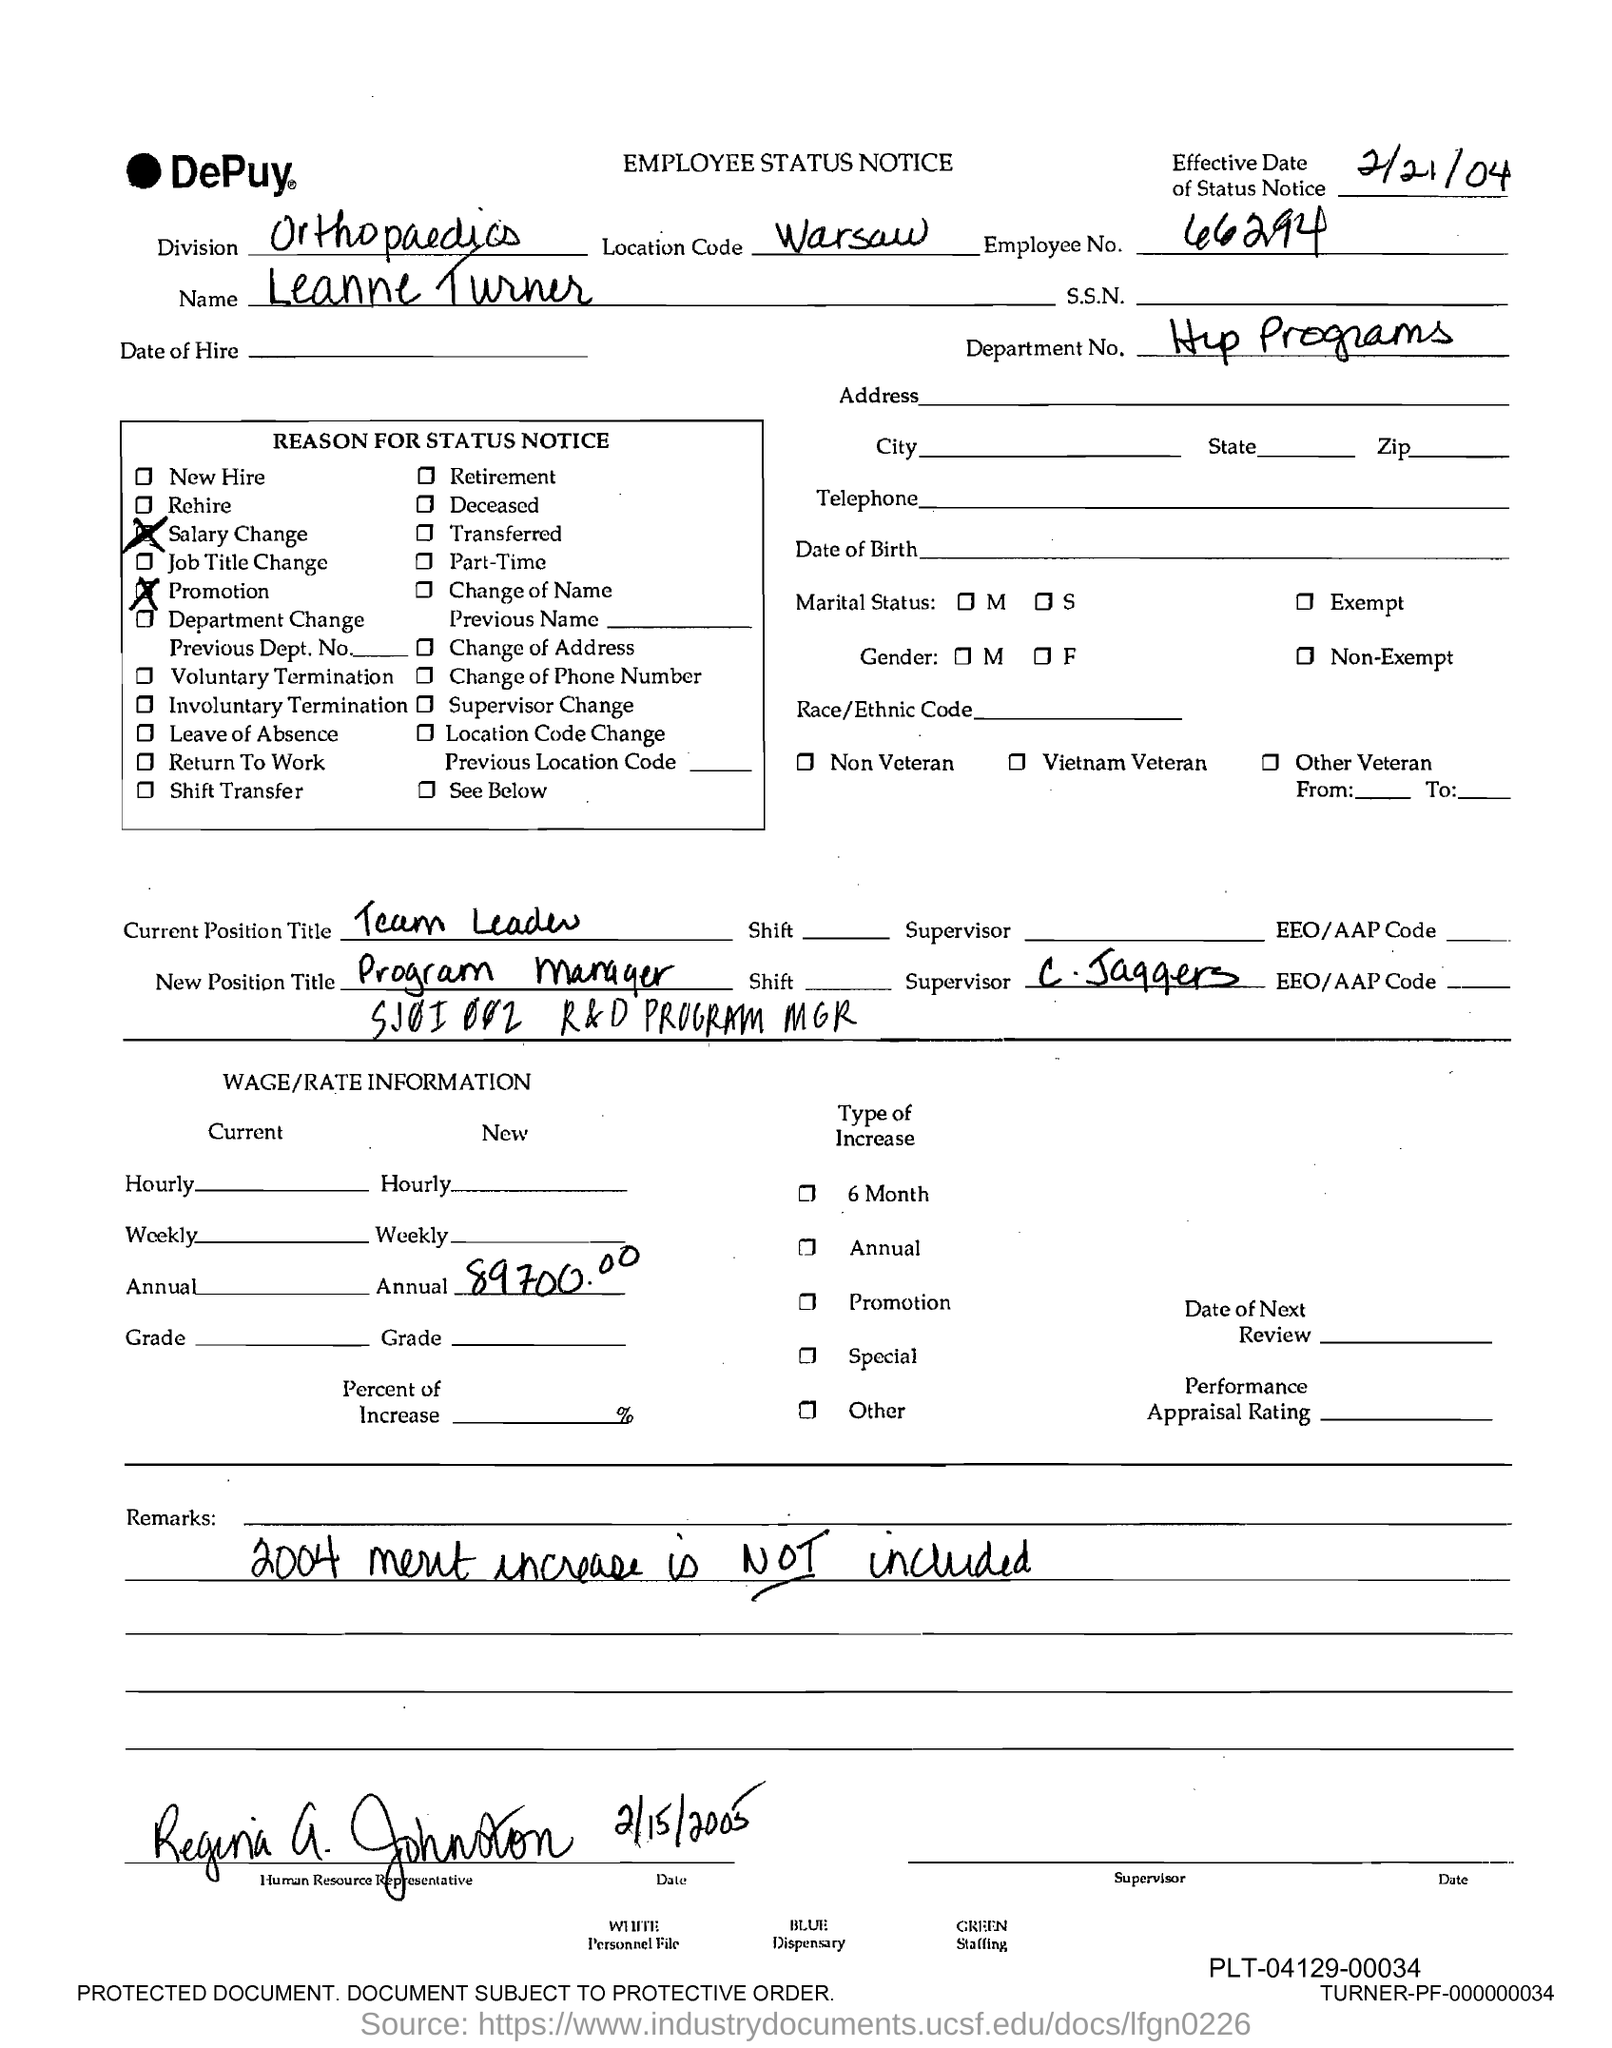Give some essential details in this illustration. The new position title is "Program Manager". The employee number is 66294... I have received new annual wage/rate information of 89,700.00. The program is located in the Department No. Hip Programs. The employee's name is Leanne Turner. 